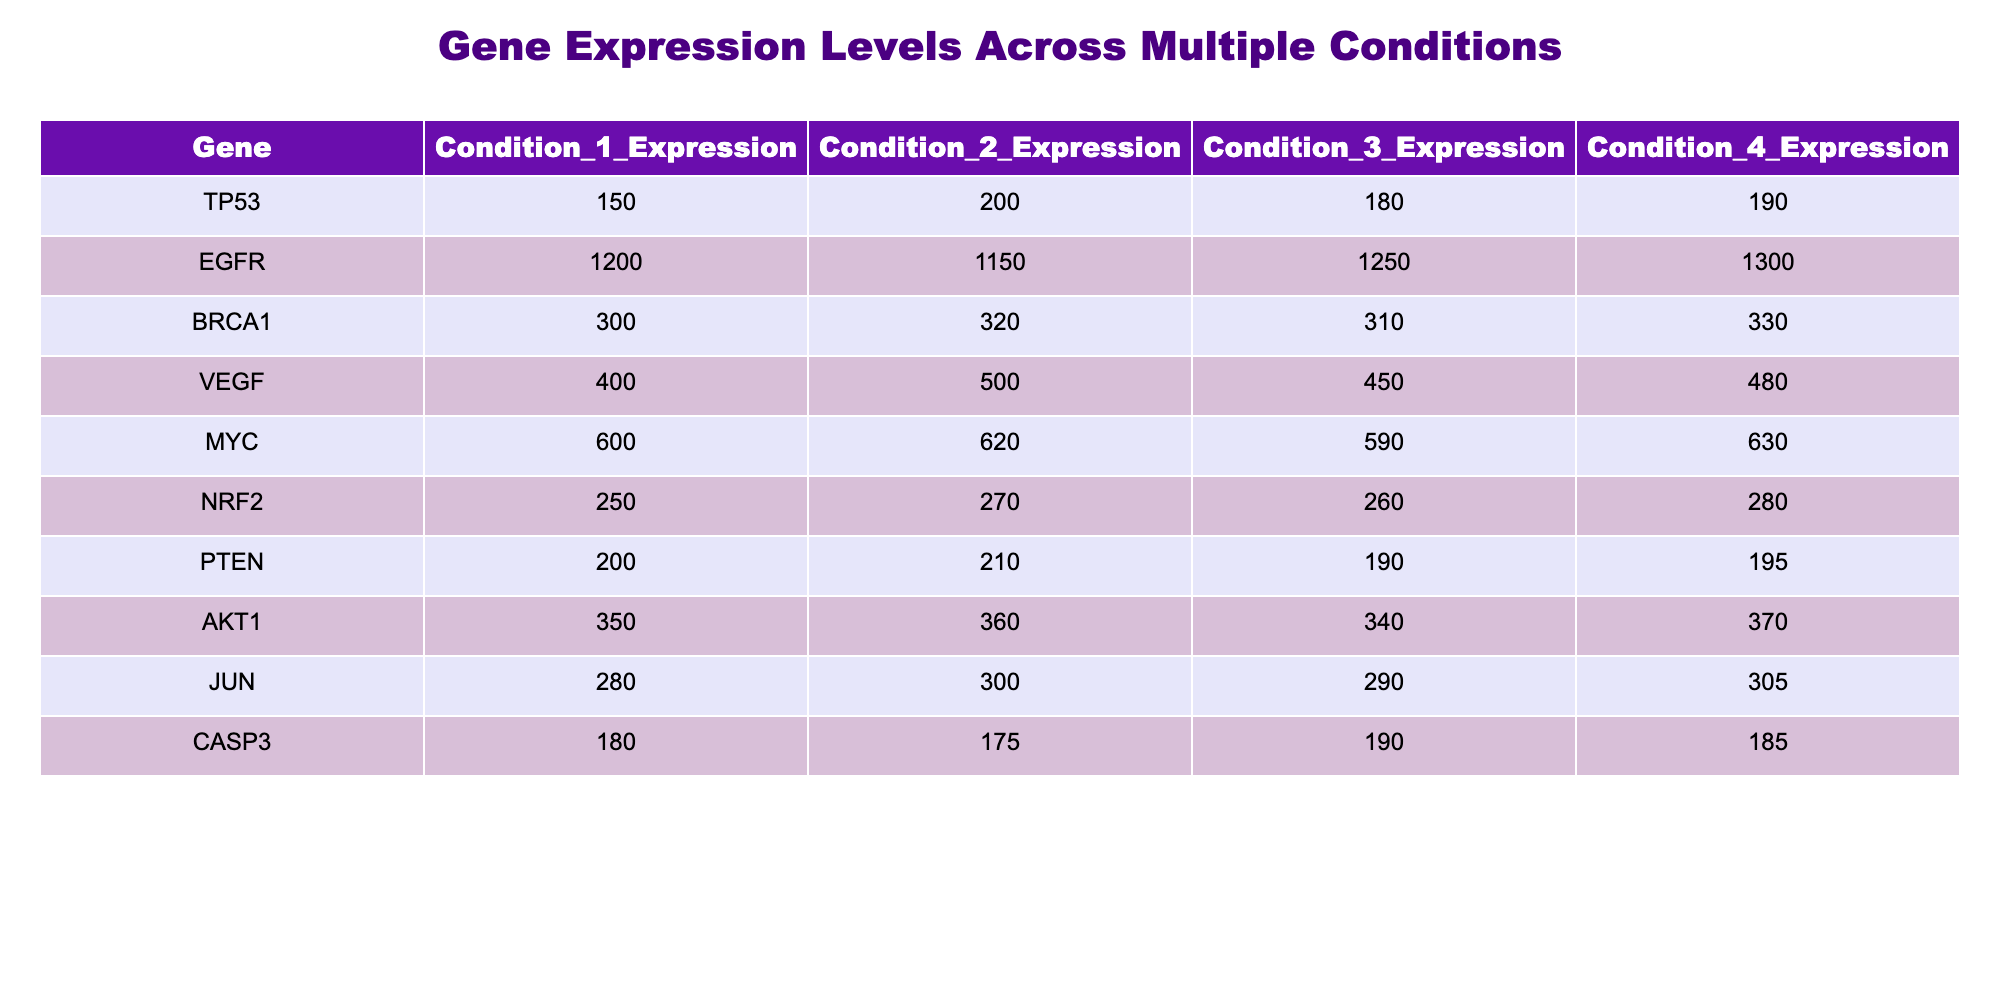What is the expression level of TP53 in Condition 2? The expression level of TP53 in Condition 2 is directly taken from the table under the respective column for TP53 and Condition 2, which shows a value of 200.
Answer: 200 What is the highest expression level among all conditions for BRCA1? For BRCA1, the expression levels in the four conditions are 300, 320, 310, and 330. The highest of these values is 330, which corresponds to Condition 4.
Answer: 330 What are the average expression levels for MYC across all conditions? To calculate the average expression levels for MYC, we sum the values from all conditions: 600 + 620 + 590 + 630 = 2440. Then, we divide this sum by the number of conditions (4), resulting in an average of 2440 / 4 = 610.
Answer: 610 Does EGFR have a higher expression level in Condition 3 than in Condition 1? The expression level of EGFR in Condition 1 is 1200, while in Condition 3 it is 1250. Since 1250 is greater than 1200, the statement is true.
Answer: Yes Which gene has the lowest expression level in Condition 1? To find the lowest expression level in Condition 1, we list all expression levels for that condition: TP53 (150), EGFR (1200), BRCA1 (300), VEGF (400), MYC (600), NRF2 (250), PTEN (200), AKT1 (350), JUN (280), and CASP3 (180). The lowest among these values is 150 for TP53.
Answer: TP53 What is the difference in expression levels for VEGF between Condition 2 and Condition 4? The expression level for VEGF in Condition 2 is 500, whereas in Condition 4 it is 480. The difference is calculated as 500 - 480 = 20.
Answer: 20 Is the expression level of CASP3 greater than 190 in Condition 4? The expression level of CASP3 in Condition 4 is 185. Since 185 is less than 190, the statement is false.
Answer: No What is the maximum expression level across all genes in Condition 3? Reviewing the expression levels in Condition 3: TP53 (180), EGFR (1250), BRCA1 (310), VEGF (450), MYC (590), NRF2 (260), PTEN (190), AKT1 (340), JUN (290), and CASP3 (190). The maximum value is 1250 for EGFR.
Answer: 1250 